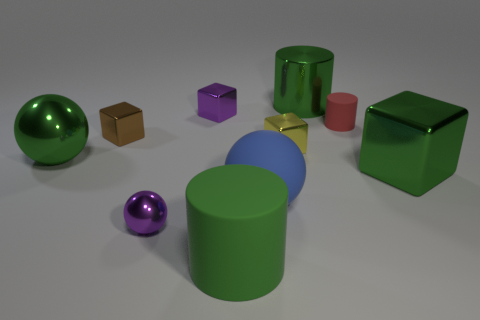Subtract all green cylinders. Subtract all gray cubes. How many cylinders are left? 1 Subtract all balls. How many objects are left? 7 Add 5 large blue matte objects. How many large blue matte objects are left? 6 Add 5 large purple rubber blocks. How many large purple rubber blocks exist? 5 Subtract 0 cyan balls. How many objects are left? 10 Subtract all red rubber cylinders. Subtract all tiny purple balls. How many objects are left? 8 